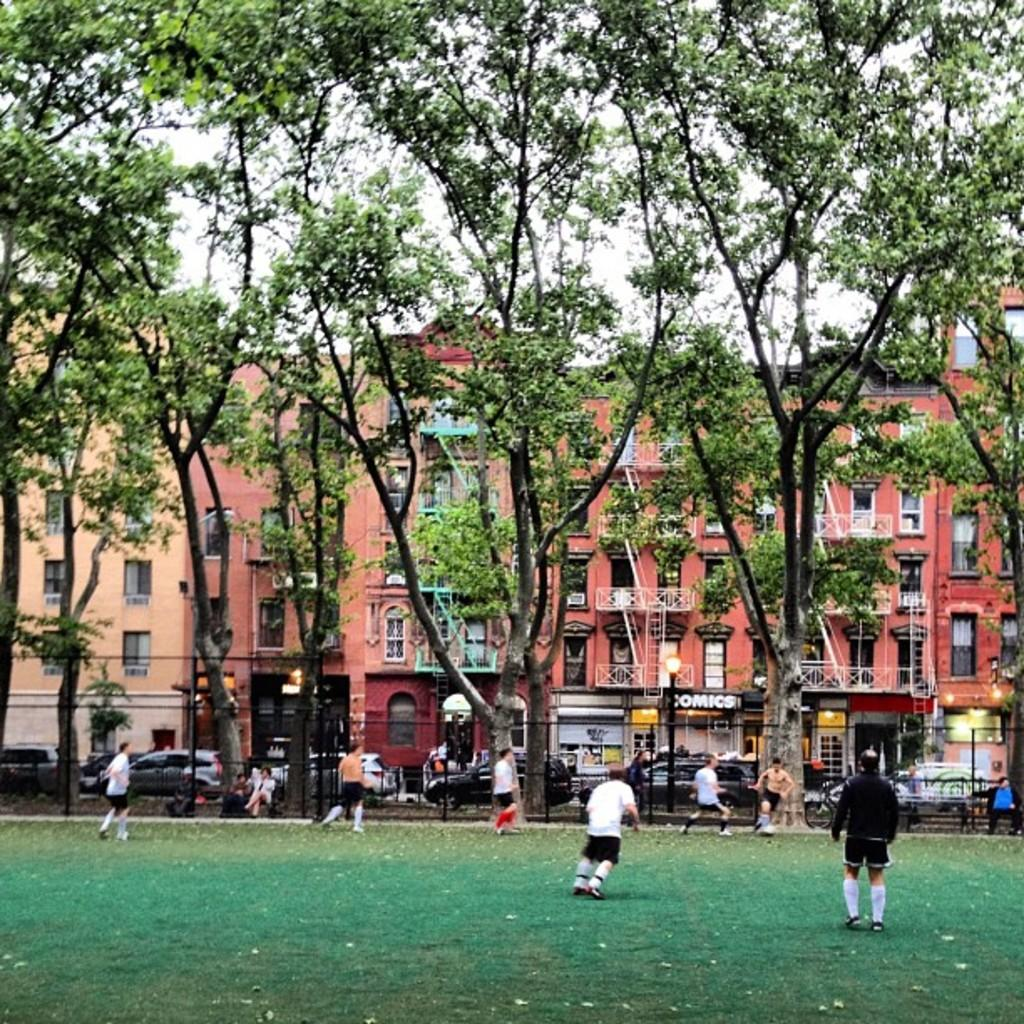What is happening on the ground in the image? There are people on the ground in the image. What can be seen in the distance behind the people? There are vehicles and trees in the background of the image. What type of structure is visible in the background? There is a building in the background of the image. How many eyes can be seen on the people in the image? There is no way to determine the number of eyes on the people in the image, as faces are not clearly visible. 